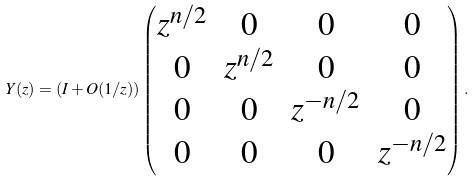<formula> <loc_0><loc_0><loc_500><loc_500>Y ( z ) = ( I + O ( 1 / z ) ) \begin{pmatrix} z ^ { n / 2 } & 0 & 0 & 0 \\ 0 & z ^ { n / 2 } & 0 & 0 \\ 0 & 0 & z ^ { - n / 2 } & 0 \\ 0 & 0 & 0 & z ^ { - n / 2 } \end{pmatrix} .</formula> 